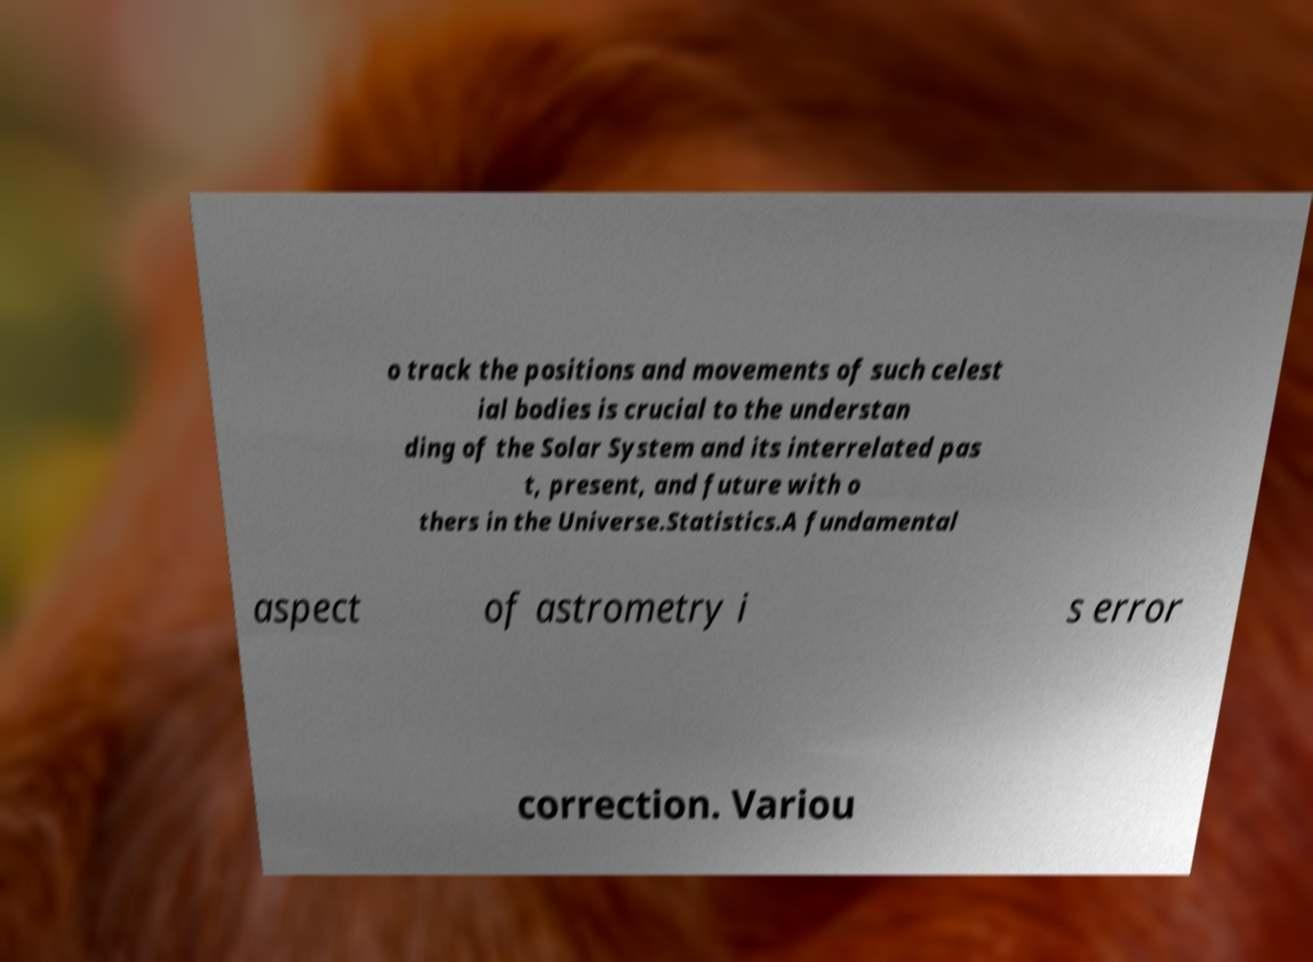What messages or text are displayed in this image? I need them in a readable, typed format. o track the positions and movements of such celest ial bodies is crucial to the understan ding of the Solar System and its interrelated pas t, present, and future with o thers in the Universe.Statistics.A fundamental aspect of astrometry i s error correction. Variou 